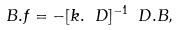<formula> <loc_0><loc_0><loc_500><loc_500>B . f = - [ k . \ D ] ^ { - 1 } \ D . B ,</formula> 